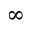Convert formula to latex. <formula><loc_0><loc_0><loc_500><loc_500>^ { \infty }</formula> 